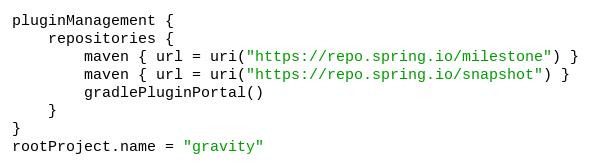Convert code to text. <code><loc_0><loc_0><loc_500><loc_500><_Kotlin_>pluginManagement {
	repositories {
		maven { url = uri("https://repo.spring.io/milestone") }
		maven { url = uri("https://repo.spring.io/snapshot") }
		gradlePluginPortal()
	}
}
rootProject.name = "gravity"
</code> 